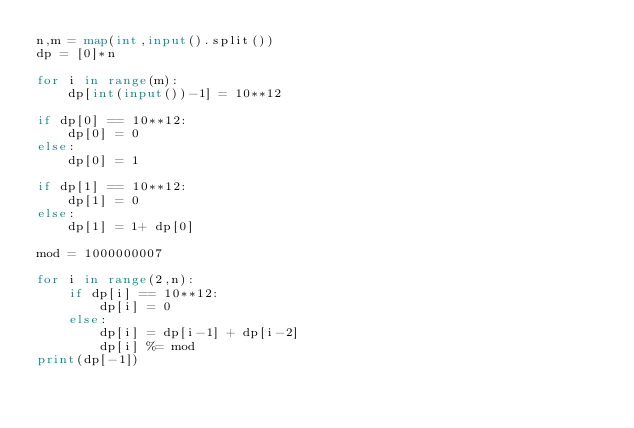<code> <loc_0><loc_0><loc_500><loc_500><_Python_>n,m = map(int,input().split())
dp = [0]*n

for i in range(m):
    dp[int(input())-1] = 10**12
    
if dp[0] == 10**12:
    dp[0] = 0
else:
    dp[0] = 1

if dp[1] == 10**12:
    dp[1] = 0
else:
    dp[1] = 1+ dp[0]

mod = 1000000007

for i in range(2,n):
    if dp[i] == 10**12:
        dp[i] = 0
    else:
        dp[i] = dp[i-1] + dp[i-2]
        dp[i] %= mod
print(dp[-1])</code> 